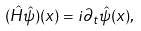<formula> <loc_0><loc_0><loc_500><loc_500>( \hat { H } \hat { \psi } ) ( x ) = i \partial _ { t } \hat { \psi } ( x ) ,</formula> 